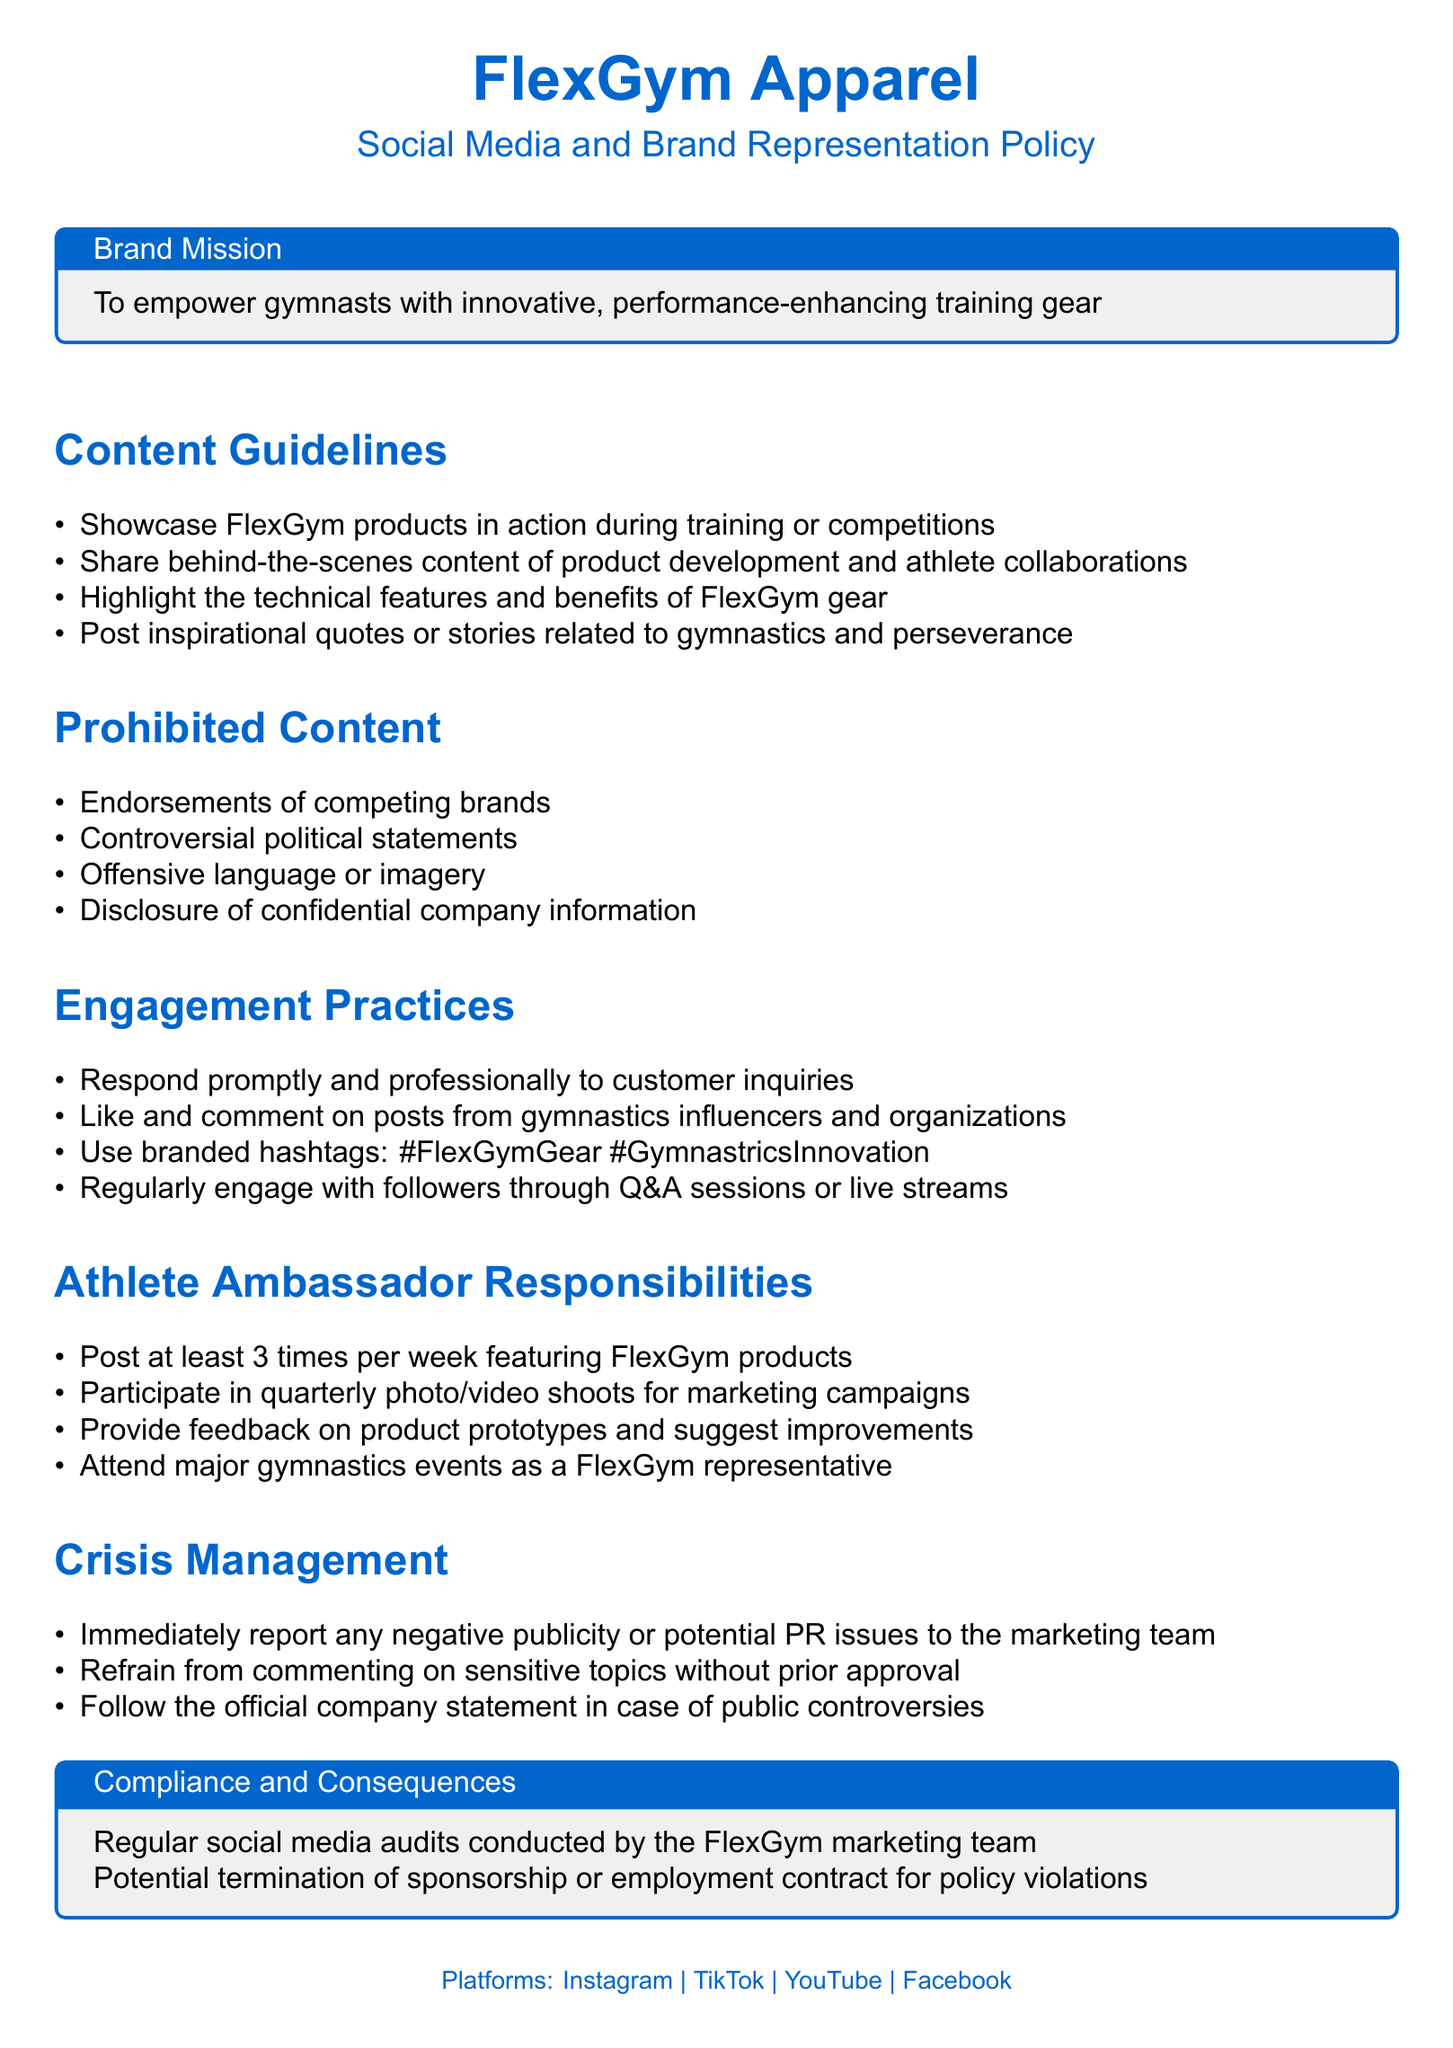What is the brand mission of FlexGym Apparel? The brand mission outlines the company's purpose and goals, which is to empower gymnasts with innovative, performance-enhancing training gear.
Answer: Empower gymnasts with innovative, performance-enhancing training gear What content should be highlighted in posts? The document lists specific types of content that should be shared to effectively represent the brand, including technical features and inspirational stories.
Answer: Technical features and benefits of FlexGym gear What is prohibited regarding competing brands? This part of the document indicates that there are specific prohibitions concerning endorsements, making clear what content should be avoided.
Answer: Endorsements of competing brands How often are athlete ambassadors required to post? The document specifies a frequency that athlete representatives must adhere to for brand promotion through their social media channels.
Answer: 3 times per week What should an athlete do during major gymnastics events? This refers to the responsibilities assigned to athlete ambassadors and the expectations during significant occasions for a brand presence.
Answer: Attend major gymnastics events as a FlexGym representative What engagement practice involves customer interaction? This question focuses on the practices that encourage active participation with the audience and how to respond to inquiries effectively.
Answer: Respond promptly and professionally to customer inquiries What action should be taken in case of negative publicity? The document outlines a specific protocol to follow when faced with potential public relations issues, indicating the importance of communication.
Answer: Immediately report any negative publicity or potential PR issues to the marketing team What happens if the policy is violated? This refers to the consequences mentioned in the document for not adhering to the outlined social media guidelines.
Answer: Potential termination of sponsorship or employment contract 